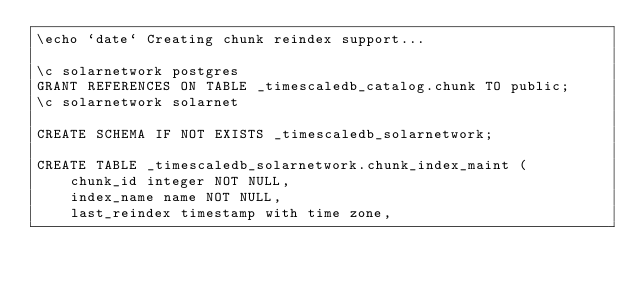Convert code to text. <code><loc_0><loc_0><loc_500><loc_500><_SQL_>\echo `date` Creating chunk reindex support...

\c solarnetwork postgres
GRANT REFERENCES ON TABLE _timescaledb_catalog.chunk TO public;
\c solarnetwork solarnet

CREATE SCHEMA IF NOT EXISTS _timescaledb_solarnetwork;

CREATE TABLE _timescaledb_solarnetwork.chunk_index_maint (
	chunk_id integer NOT NULL,
	index_name name NOT NULL,
	last_reindex timestamp with time zone,</code> 